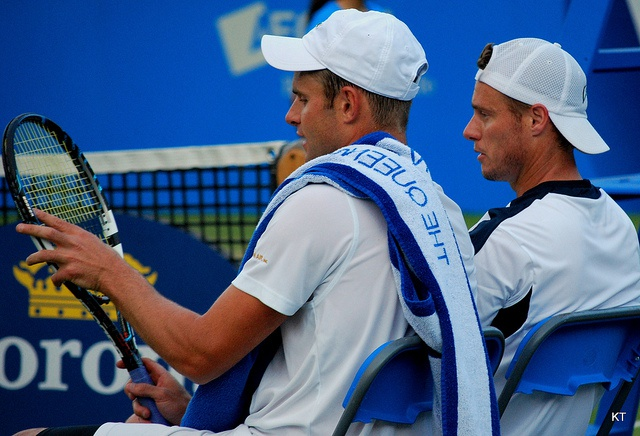Describe the objects in this image and their specific colors. I can see people in navy, darkgray, and lightblue tones, people in navy, darkgray, lightblue, and black tones, tennis racket in navy, black, brown, and darkgray tones, chair in navy, black, darkblue, and gray tones, and chair in navy, black, darkblue, and gray tones in this image. 